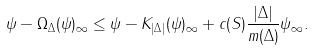Convert formula to latex. <formula><loc_0><loc_0><loc_500><loc_500>\| \psi - \Omega _ { \Delta } ( \psi ) \| _ { \infty } \leq \| \psi - K _ { | \Delta | } ( \psi ) \| _ { \infty } + c ( S ) \frac { | \Delta | } { m ( \Delta ) } \| \psi \| _ { \infty } .</formula> 